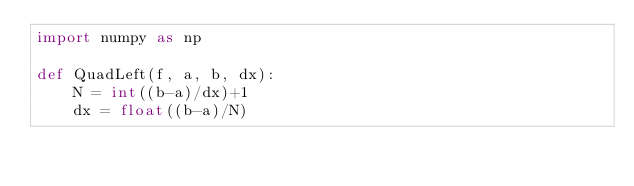Convert code to text. <code><loc_0><loc_0><loc_500><loc_500><_Python_>import numpy as np 

def QuadLeft(f, a, b, dx):
    N = int((b-a)/dx)+1
    dx = float((b-a)/N)</code> 